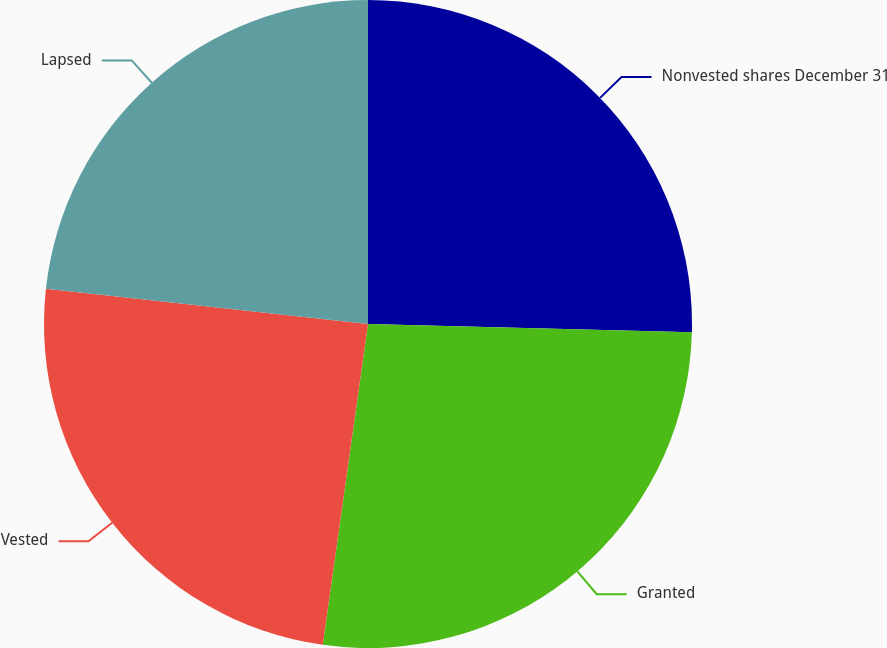<chart> <loc_0><loc_0><loc_500><loc_500><pie_chart><fcel>Nonvested shares December 31<fcel>Granted<fcel>Vested<fcel>Lapsed<nl><fcel>25.41%<fcel>26.82%<fcel>24.51%<fcel>23.26%<nl></chart> 